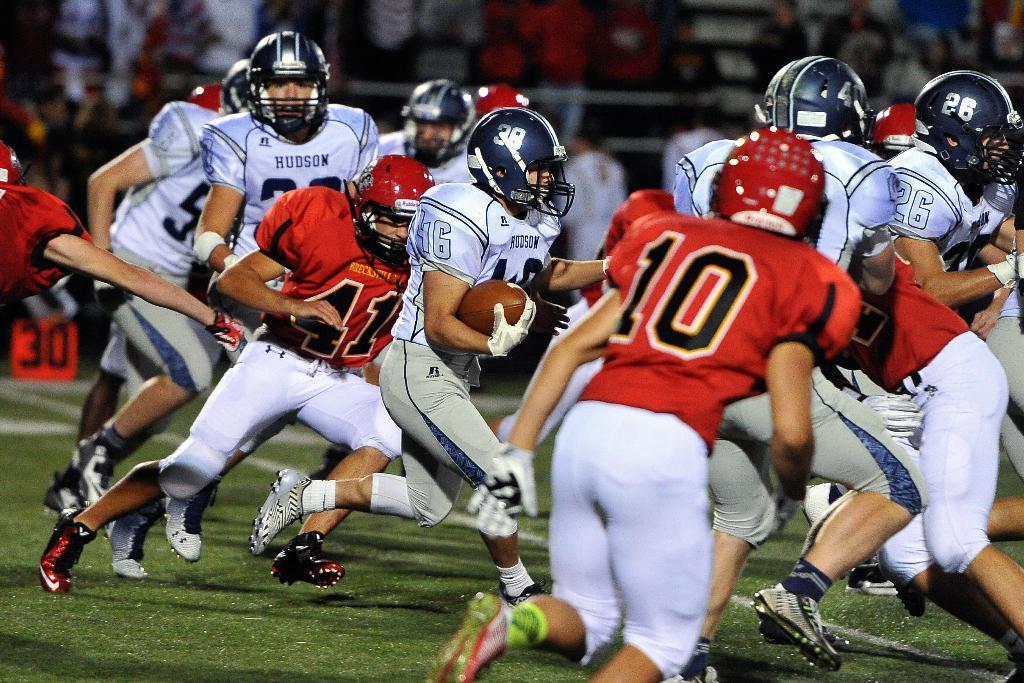Please provide a concise description of this image. In this image we can see a few people wearing sports dress and one among them is holding a ball and it looks like they are playing. In the background, we can see the image is blurred. 